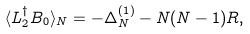Convert formula to latex. <formula><loc_0><loc_0><loc_500><loc_500>\langle L _ { 2 } ^ { \dag } B _ { 0 } \rangle _ { N } = - \Delta _ { N } ^ { ( 1 ) } - N ( N - 1 ) R ,</formula> 